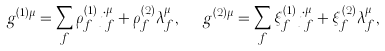Convert formula to latex. <formula><loc_0><loc_0><loc_500><loc_500>g ^ { ( 1 ) \mu } = \sum _ { f } \rho ^ { ( 1 ) } _ { f } j _ { f } ^ { \mu } + \rho ^ { ( 2 ) } _ { f } \lambda _ { f } ^ { \mu } , \ \ g ^ { ( 2 ) \mu } = \sum _ { f } \xi ^ { ( 1 ) } _ { f } j _ { f } ^ { \mu } + \xi ^ { ( 2 ) } _ { f } \lambda _ { f } ^ { \mu } ,</formula> 